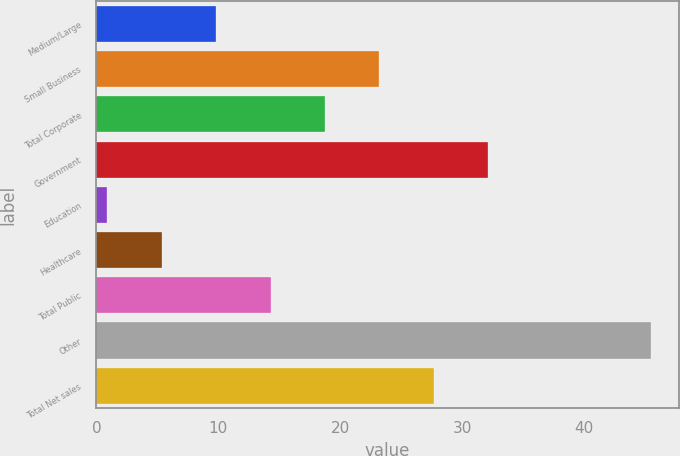<chart> <loc_0><loc_0><loc_500><loc_500><bar_chart><fcel>Medium/Large<fcel>Small Business<fcel>Total Corporate<fcel>Government<fcel>Education<fcel>Healthcare<fcel>Total Public<fcel>Other<fcel>Total Net sales<nl><fcel>9.82<fcel>23.2<fcel>18.74<fcel>32.12<fcel>0.9<fcel>5.36<fcel>14.28<fcel>45.5<fcel>27.66<nl></chart> 